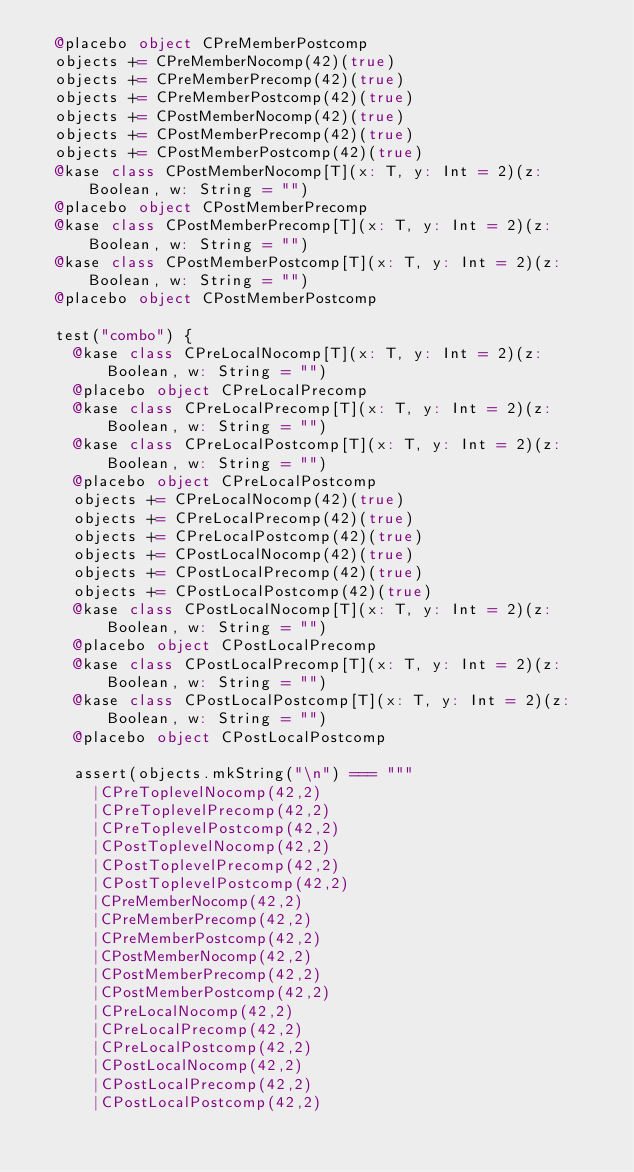<code> <loc_0><loc_0><loc_500><loc_500><_Scala_>  @placebo object CPreMemberPostcomp
  objects += CPreMemberNocomp(42)(true)
  objects += CPreMemberPrecomp(42)(true)
  objects += CPreMemberPostcomp(42)(true)
  objects += CPostMemberNocomp(42)(true)
  objects += CPostMemberPrecomp(42)(true)
  objects += CPostMemberPostcomp(42)(true)
  @kase class CPostMemberNocomp[T](x: T, y: Int = 2)(z: Boolean, w: String = "")
  @placebo object CPostMemberPrecomp
  @kase class CPostMemberPrecomp[T](x: T, y: Int = 2)(z: Boolean, w: String = "")
  @kase class CPostMemberPostcomp[T](x: T, y: Int = 2)(z: Boolean, w: String = "")
  @placebo object CPostMemberPostcomp

  test("combo") {
    @kase class CPreLocalNocomp[T](x: T, y: Int = 2)(z: Boolean, w: String = "")
    @placebo object CPreLocalPrecomp
    @kase class CPreLocalPrecomp[T](x: T, y: Int = 2)(z: Boolean, w: String = "")
    @kase class CPreLocalPostcomp[T](x: T, y: Int = 2)(z: Boolean, w: String = "")
    @placebo object CPreLocalPostcomp
    objects += CPreLocalNocomp(42)(true)
    objects += CPreLocalPrecomp(42)(true)
    objects += CPreLocalPostcomp(42)(true)
    objects += CPostLocalNocomp(42)(true)
    objects += CPostLocalPrecomp(42)(true)
    objects += CPostLocalPostcomp(42)(true)
    @kase class CPostLocalNocomp[T](x: T, y: Int = 2)(z: Boolean, w: String = "")
    @placebo object CPostLocalPrecomp
    @kase class CPostLocalPrecomp[T](x: T, y: Int = 2)(z: Boolean, w: String = "")
    @kase class CPostLocalPostcomp[T](x: T, y: Int = 2)(z: Boolean, w: String = "")
    @placebo object CPostLocalPostcomp

    assert(objects.mkString("\n") === """
      |CPreToplevelNocomp(42,2)
      |CPreToplevelPrecomp(42,2)
      |CPreToplevelPostcomp(42,2)
      |CPostToplevelNocomp(42,2)
      |CPostToplevelPrecomp(42,2)
      |CPostToplevelPostcomp(42,2)
      |CPreMemberNocomp(42,2)
      |CPreMemberPrecomp(42,2)
      |CPreMemberPostcomp(42,2)
      |CPostMemberNocomp(42,2)
      |CPostMemberPrecomp(42,2)
      |CPostMemberPostcomp(42,2)
      |CPreLocalNocomp(42,2)
      |CPreLocalPrecomp(42,2)
      |CPreLocalPostcomp(42,2)
      |CPostLocalNocomp(42,2)
      |CPostLocalPrecomp(42,2)
      |CPostLocalPostcomp(42,2)</code> 